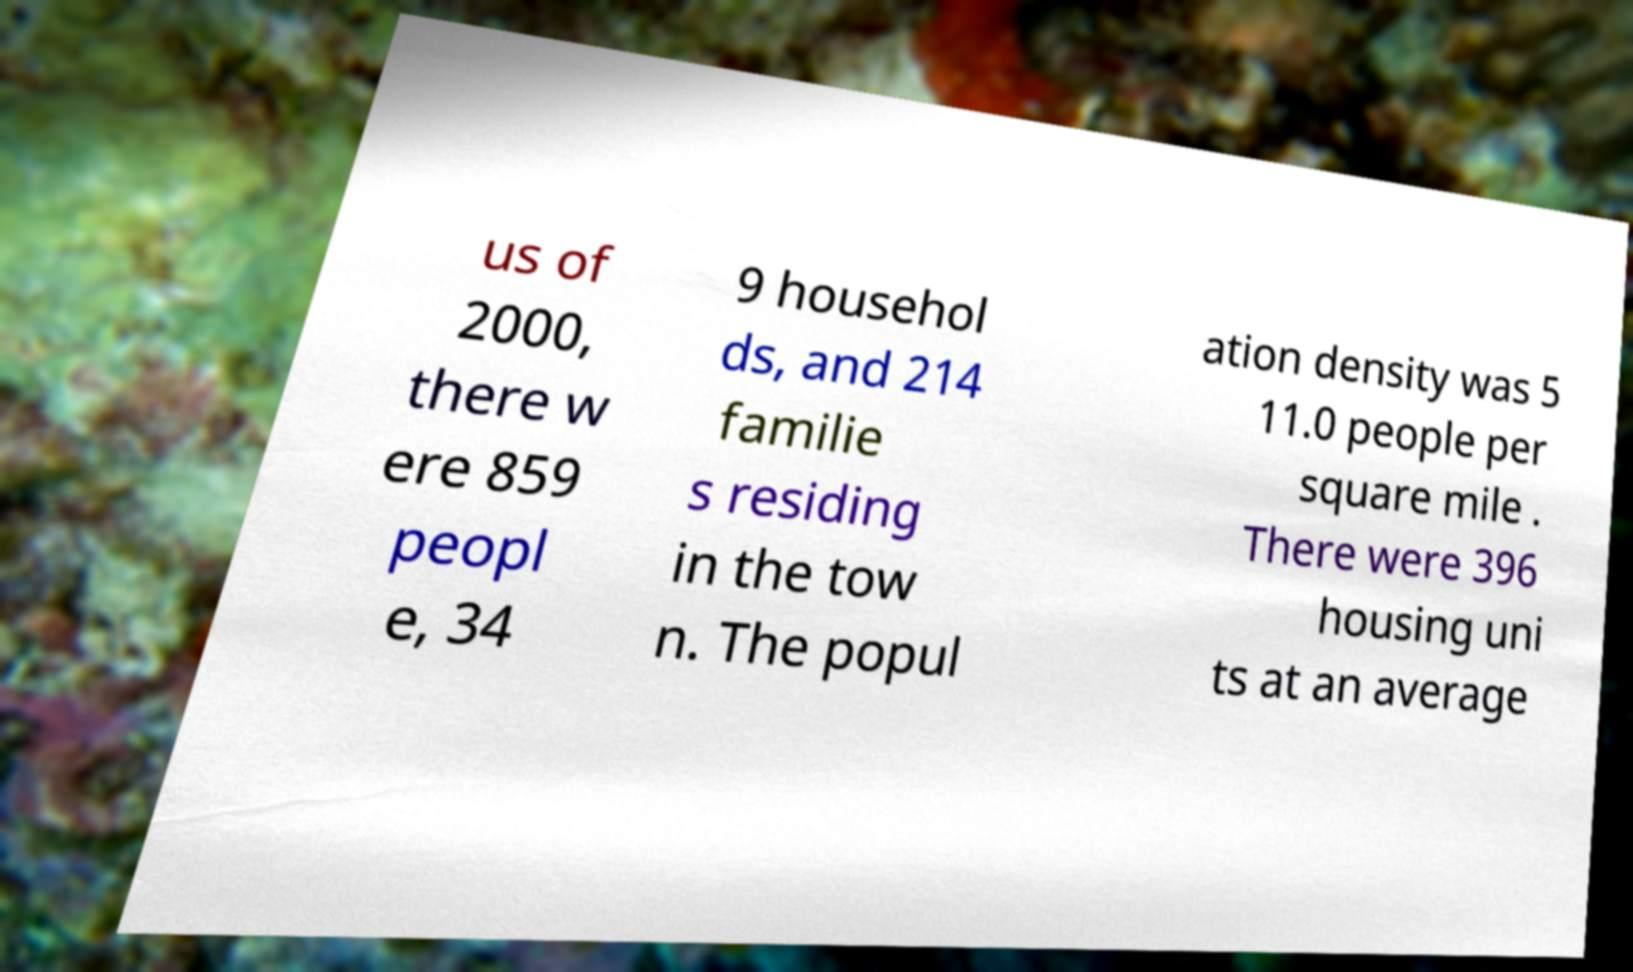I need the written content from this picture converted into text. Can you do that? us of 2000, there w ere 859 peopl e, 34 9 househol ds, and 214 familie s residing in the tow n. The popul ation density was 5 11.0 people per square mile . There were 396 housing uni ts at an average 